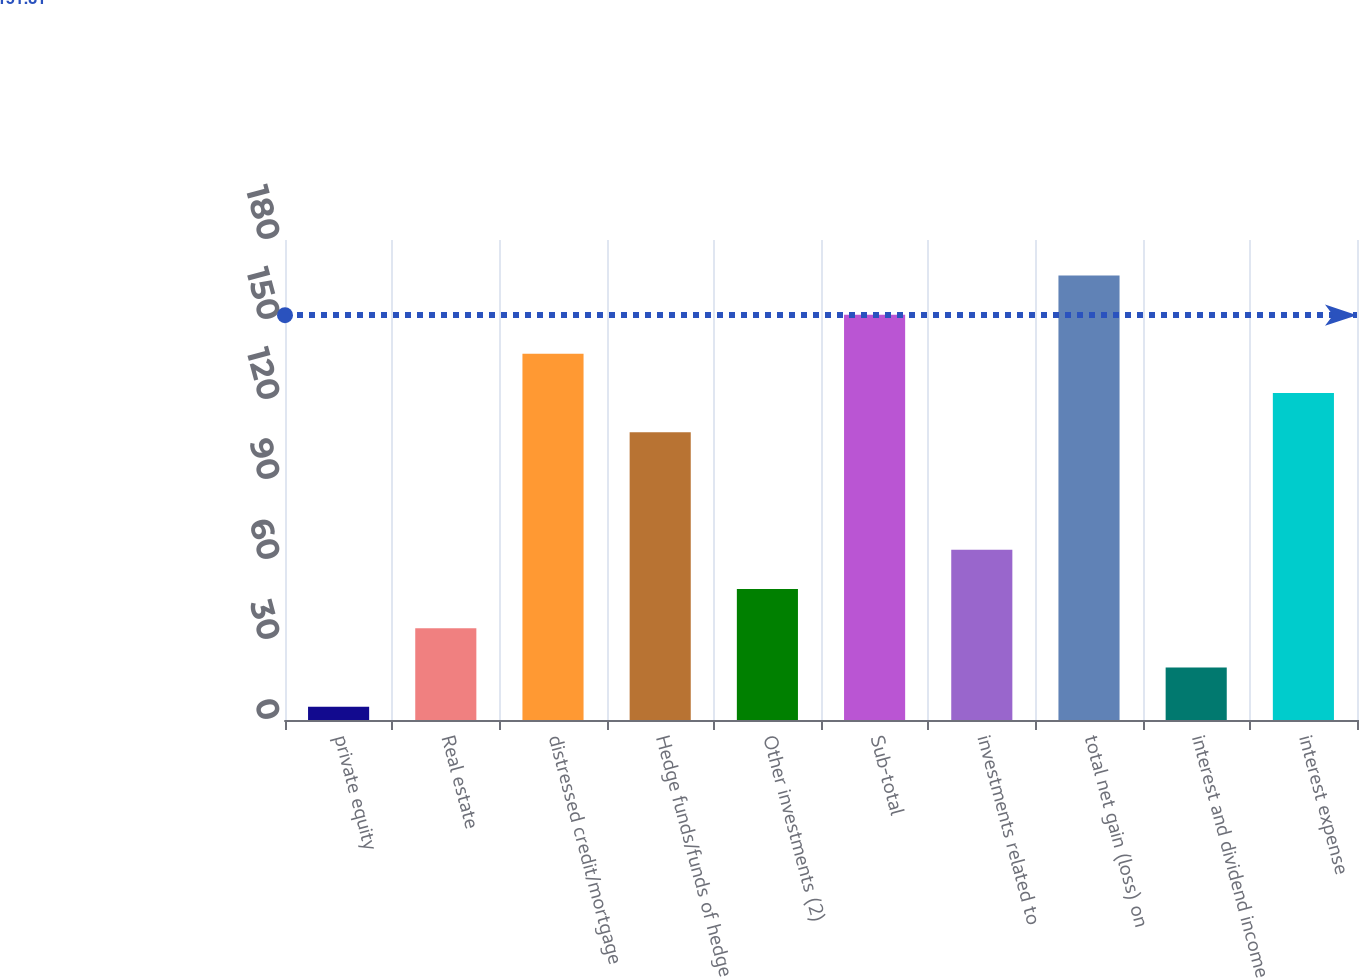<chart> <loc_0><loc_0><loc_500><loc_500><bar_chart><fcel>private equity<fcel>Real estate<fcel>distressed credit/mortgage<fcel>Hedge funds/funds of hedge<fcel>Other investments (2)<fcel>Sub-total<fcel>investments related to<fcel>total net gain (loss) on<fcel>interest and dividend income<fcel>interest expense<nl><fcel>5<fcel>34.4<fcel>137.3<fcel>107.9<fcel>49.1<fcel>152<fcel>63.8<fcel>166.7<fcel>19.7<fcel>122.6<nl></chart> 